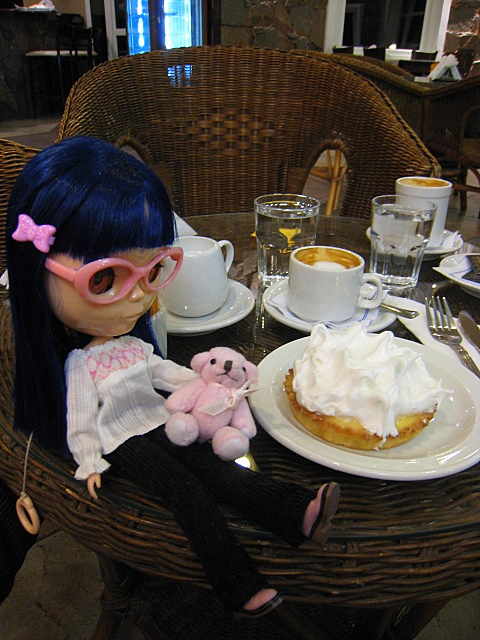<image>What does the big word say on the teddy bears shirt? There are no words on the teddy bear's shirt. What does the big word say on the teddy bears shirt? There is no big word on the teddy bear's shirt. 